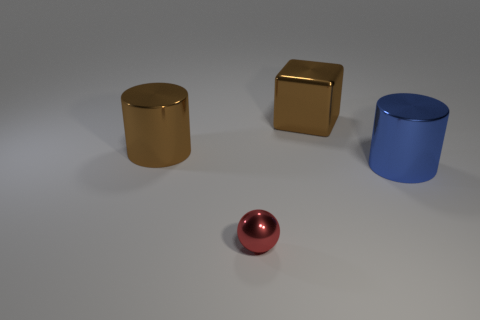Is there anything else that has the same shape as the small metallic thing?
Provide a succinct answer. No. Does the blue thing have the same size as the red shiny object?
Offer a very short reply. No. What material is the other large object that is the same shape as the blue metal thing?
Offer a terse response. Metal. Is there anything else that has the same material as the tiny sphere?
Your answer should be very brief. Yes. How many green things are big metallic cubes or large metallic cylinders?
Make the answer very short. 0. What is the material of the brown object that is right of the tiny thing?
Your answer should be very brief. Metal. Are there more large brown blocks than large metal things?
Ensure brevity in your answer.  No. Is the shape of the large brown metallic thing that is to the right of the red metal ball the same as  the small object?
Your answer should be compact. No. How many things are in front of the block and behind the red metallic object?
Provide a succinct answer. 2. What number of brown metal objects have the same shape as the blue object?
Ensure brevity in your answer.  1. 